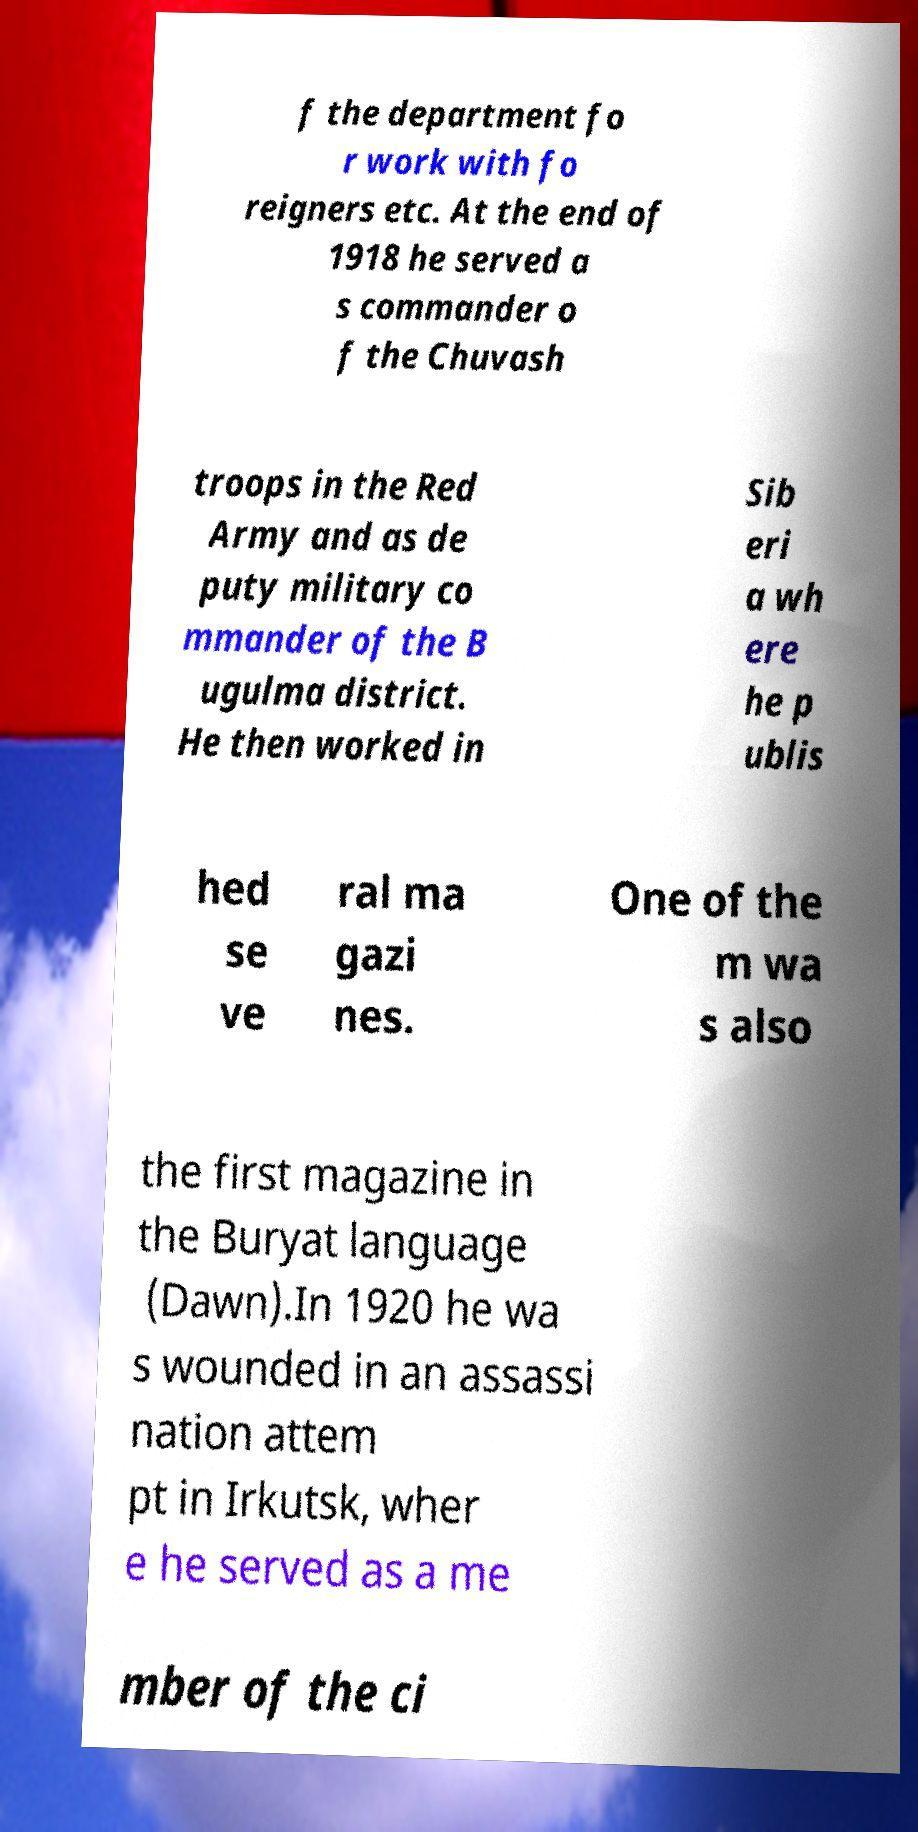Could you assist in decoding the text presented in this image and type it out clearly? f the department fo r work with fo reigners etc. At the end of 1918 he served a s commander o f the Chuvash troops in the Red Army and as de puty military co mmander of the B ugulma district. He then worked in Sib eri a wh ere he p ublis hed se ve ral ma gazi nes. One of the m wa s also the first magazine in the Buryat language (Dawn).In 1920 he wa s wounded in an assassi nation attem pt in Irkutsk, wher e he served as a me mber of the ci 